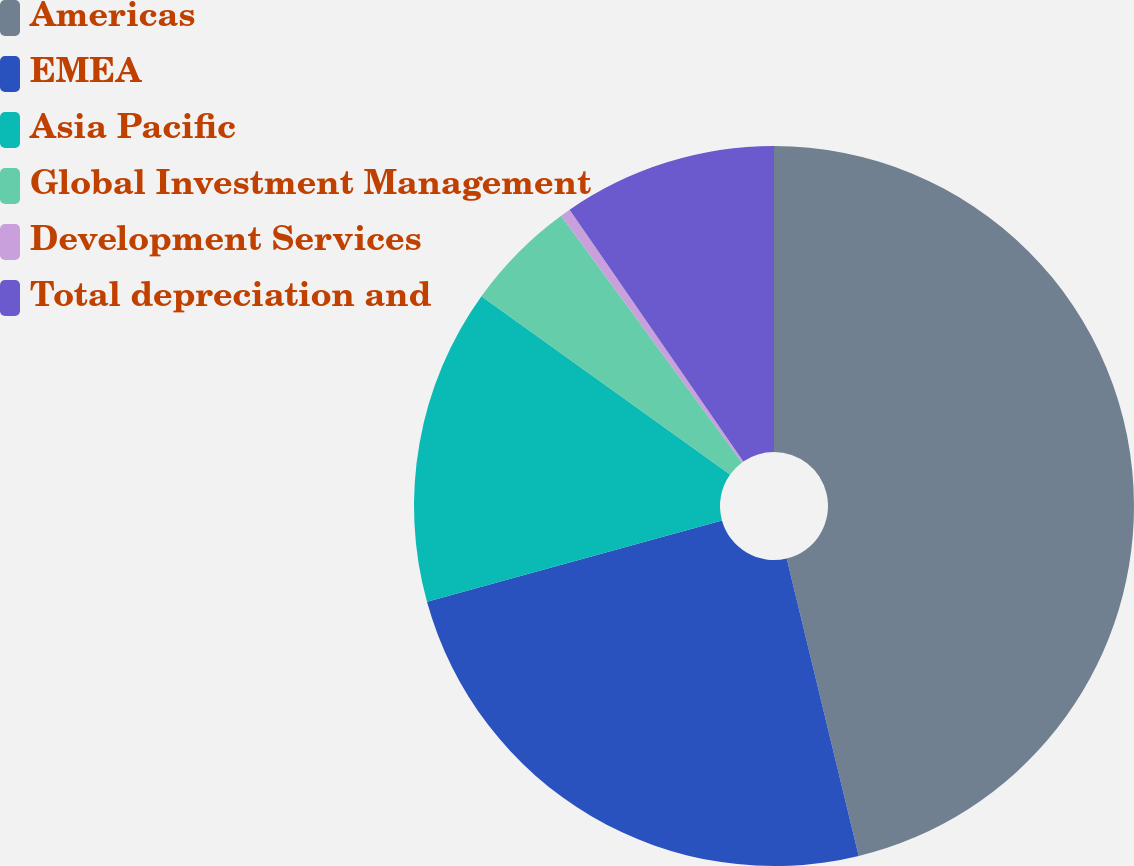<chart> <loc_0><loc_0><loc_500><loc_500><pie_chart><fcel>Americas<fcel>EMEA<fcel>Asia Pacific<fcel>Global Investment Management<fcel>Development Services<fcel>Total depreciation and<nl><fcel>46.22%<fcel>24.49%<fcel>14.19%<fcel>5.03%<fcel>0.46%<fcel>9.61%<nl></chart> 